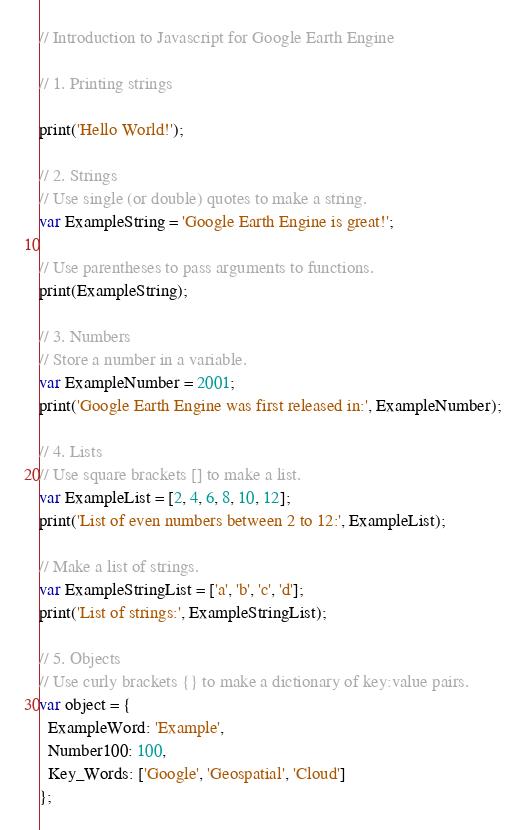<code> <loc_0><loc_0><loc_500><loc_500><_JavaScript_>// Introduction to Javascript for Google Earth Engine

// 1. Printing strings

print('Hello World!');

// 2. Strings
// Use single (or double) quotes to make a string.
var ExampleString = 'Google Earth Engine is great!';

// Use parentheses to pass arguments to functions.
print(ExampleString);

// 3. Numbers
// Store a number in a variable.
var ExampleNumber = 2001;
print('Google Earth Engine was first released in:', ExampleNumber);

// 4. Lists 
// Use square brackets [] to make a list.
var ExampleList = [2, 4, 6, 8, 10, 12];
print('List of even numbers between 2 to 12:', ExampleList);

// Make a list of strings.
var ExampleStringList = ['a', 'b', 'c', 'd'];
print('List of strings:', ExampleStringList);

// 5. Objects
// Use curly brackets {} to make a dictionary of key:value pairs.
var object = {
  ExampleWord: 'Example',
  Number100: 100,
  Key_Words: ['Google', 'Geospatial', 'Cloud']
};</code> 